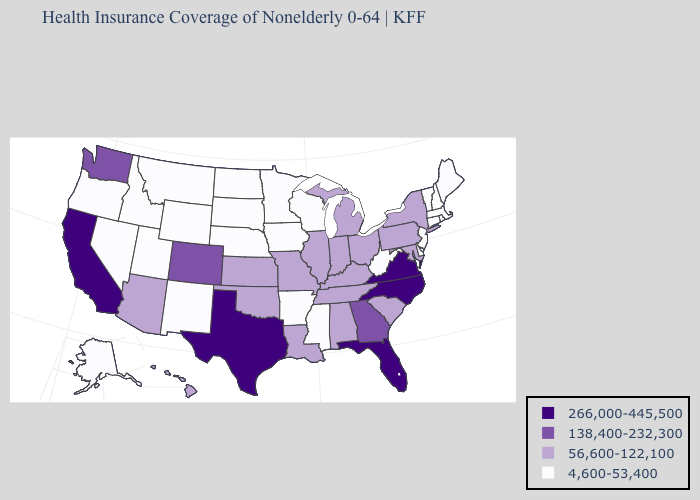What is the value of California?
Short answer required. 266,000-445,500. Name the states that have a value in the range 56,600-122,100?
Short answer required. Alabama, Arizona, Hawaii, Illinois, Indiana, Kansas, Kentucky, Louisiana, Maryland, Michigan, Missouri, New York, Ohio, Oklahoma, Pennsylvania, South Carolina, Tennessee. What is the value of Michigan?
Keep it brief. 56,600-122,100. Name the states that have a value in the range 56,600-122,100?
Be succinct. Alabama, Arizona, Hawaii, Illinois, Indiana, Kansas, Kentucky, Louisiana, Maryland, Michigan, Missouri, New York, Ohio, Oklahoma, Pennsylvania, South Carolina, Tennessee. Is the legend a continuous bar?
Concise answer only. No. Among the states that border Kentucky , does Virginia have the lowest value?
Answer briefly. No. Does Maryland have the lowest value in the USA?
Write a very short answer. No. Does Delaware have the lowest value in the South?
Keep it brief. Yes. What is the value of Florida?
Answer briefly. 266,000-445,500. What is the highest value in the South ?
Be succinct. 266,000-445,500. Name the states that have a value in the range 56,600-122,100?
Keep it brief. Alabama, Arizona, Hawaii, Illinois, Indiana, Kansas, Kentucky, Louisiana, Maryland, Michigan, Missouri, New York, Ohio, Oklahoma, Pennsylvania, South Carolina, Tennessee. Does the map have missing data?
Write a very short answer. No. What is the lowest value in the USA?
Give a very brief answer. 4,600-53,400. Name the states that have a value in the range 138,400-232,300?
Give a very brief answer. Colorado, Georgia, Washington. Which states have the lowest value in the USA?
Keep it brief. Alaska, Arkansas, Connecticut, Delaware, Idaho, Iowa, Maine, Massachusetts, Minnesota, Mississippi, Montana, Nebraska, Nevada, New Hampshire, New Jersey, New Mexico, North Dakota, Oregon, Rhode Island, South Dakota, Utah, Vermont, West Virginia, Wisconsin, Wyoming. 